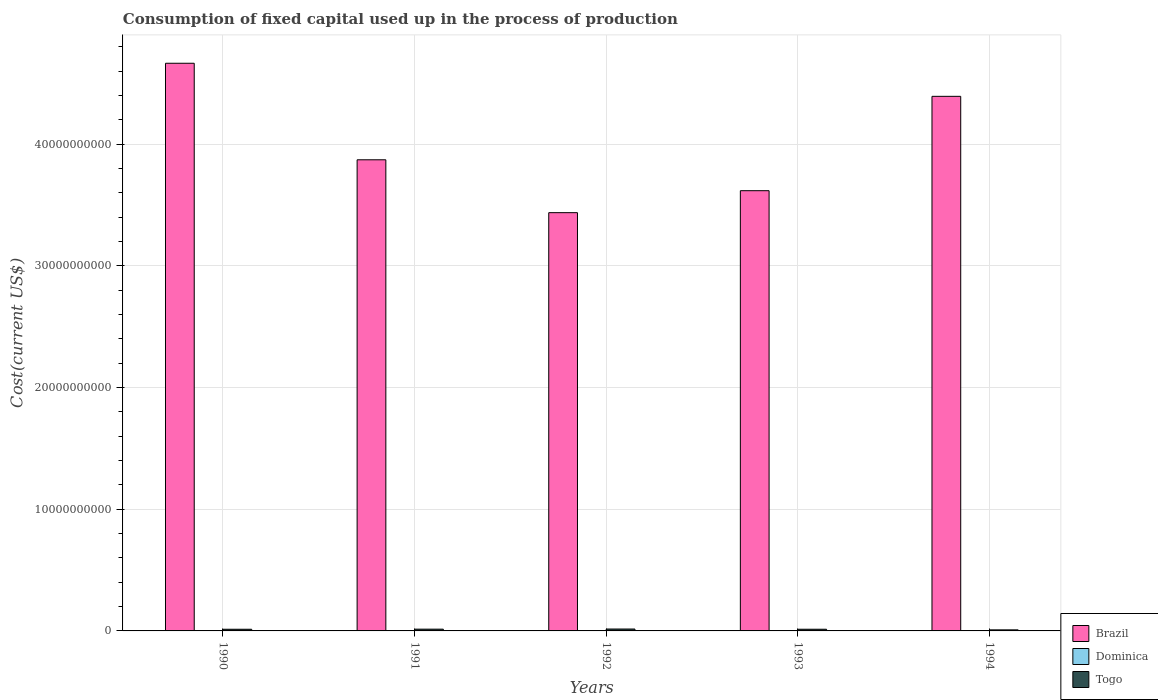How many groups of bars are there?
Provide a short and direct response. 5. Are the number of bars per tick equal to the number of legend labels?
Your answer should be very brief. Yes. Are the number of bars on each tick of the X-axis equal?
Keep it short and to the point. Yes. How many bars are there on the 4th tick from the left?
Provide a short and direct response. 3. In how many cases, is the number of bars for a given year not equal to the number of legend labels?
Keep it short and to the point. 0. What is the amount consumed in the process of production in Brazil in 1994?
Your response must be concise. 4.39e+1. Across all years, what is the maximum amount consumed in the process of production in Togo?
Offer a terse response. 1.56e+08. Across all years, what is the minimum amount consumed in the process of production in Brazil?
Your answer should be very brief. 3.44e+1. In which year was the amount consumed in the process of production in Dominica minimum?
Keep it short and to the point. 1990. What is the total amount consumed in the process of production in Dominica in the graph?
Your answer should be very brief. 4.10e+07. What is the difference between the amount consumed in the process of production in Dominica in 1992 and that in 1993?
Provide a short and direct response. -5.16e+05. What is the difference between the amount consumed in the process of production in Dominica in 1992 and the amount consumed in the process of production in Brazil in 1990?
Make the answer very short. -4.66e+1. What is the average amount consumed in the process of production in Brazil per year?
Your response must be concise. 4.00e+1. In the year 1994, what is the difference between the amount consumed in the process of production in Brazil and amount consumed in the process of production in Dominica?
Provide a short and direct response. 4.39e+1. In how many years, is the amount consumed in the process of production in Dominica greater than 36000000000 US$?
Your answer should be compact. 0. What is the ratio of the amount consumed in the process of production in Brazil in 1990 to that in 1991?
Provide a succinct answer. 1.2. What is the difference between the highest and the second highest amount consumed in the process of production in Brazil?
Keep it short and to the point. 2.72e+09. What is the difference between the highest and the lowest amount consumed in the process of production in Togo?
Ensure brevity in your answer.  6.89e+07. In how many years, is the amount consumed in the process of production in Togo greater than the average amount consumed in the process of production in Togo taken over all years?
Make the answer very short. 4. Is it the case that in every year, the sum of the amount consumed in the process of production in Brazil and amount consumed in the process of production in Dominica is greater than the amount consumed in the process of production in Togo?
Ensure brevity in your answer.  Yes. Are all the bars in the graph horizontal?
Give a very brief answer. No. How many years are there in the graph?
Your answer should be compact. 5. Are the values on the major ticks of Y-axis written in scientific E-notation?
Offer a terse response. No. Does the graph contain any zero values?
Your response must be concise. No. Does the graph contain grids?
Provide a succinct answer. Yes. What is the title of the graph?
Provide a short and direct response. Consumption of fixed capital used up in the process of production. What is the label or title of the X-axis?
Ensure brevity in your answer.  Years. What is the label or title of the Y-axis?
Make the answer very short. Cost(current US$). What is the Cost(current US$) in Brazil in 1990?
Make the answer very short. 4.66e+1. What is the Cost(current US$) in Dominica in 1990?
Provide a short and direct response. 6.67e+06. What is the Cost(current US$) in Togo in 1990?
Ensure brevity in your answer.  1.37e+08. What is the Cost(current US$) of Brazil in 1991?
Your answer should be compact. 3.87e+1. What is the Cost(current US$) in Dominica in 1991?
Keep it short and to the point. 7.73e+06. What is the Cost(current US$) in Togo in 1991?
Offer a terse response. 1.44e+08. What is the Cost(current US$) of Brazil in 1992?
Give a very brief answer. 3.44e+1. What is the Cost(current US$) in Dominica in 1992?
Give a very brief answer. 8.29e+06. What is the Cost(current US$) of Togo in 1992?
Your answer should be very brief. 1.56e+08. What is the Cost(current US$) in Brazil in 1993?
Your answer should be very brief. 3.62e+1. What is the Cost(current US$) of Dominica in 1993?
Give a very brief answer. 8.80e+06. What is the Cost(current US$) in Togo in 1993?
Offer a terse response. 1.38e+08. What is the Cost(current US$) in Brazil in 1994?
Make the answer very short. 4.39e+1. What is the Cost(current US$) of Dominica in 1994?
Your response must be concise. 9.56e+06. What is the Cost(current US$) in Togo in 1994?
Ensure brevity in your answer.  8.72e+07. Across all years, what is the maximum Cost(current US$) in Brazil?
Ensure brevity in your answer.  4.66e+1. Across all years, what is the maximum Cost(current US$) in Dominica?
Provide a short and direct response. 9.56e+06. Across all years, what is the maximum Cost(current US$) in Togo?
Your answer should be very brief. 1.56e+08. Across all years, what is the minimum Cost(current US$) of Brazil?
Give a very brief answer. 3.44e+1. Across all years, what is the minimum Cost(current US$) in Dominica?
Your answer should be very brief. 6.67e+06. Across all years, what is the minimum Cost(current US$) of Togo?
Provide a short and direct response. 8.72e+07. What is the total Cost(current US$) of Brazil in the graph?
Your answer should be very brief. 2.00e+11. What is the total Cost(current US$) in Dominica in the graph?
Offer a terse response. 4.10e+07. What is the total Cost(current US$) in Togo in the graph?
Your answer should be very brief. 6.63e+08. What is the difference between the Cost(current US$) in Brazil in 1990 and that in 1991?
Offer a very short reply. 7.93e+09. What is the difference between the Cost(current US$) in Dominica in 1990 and that in 1991?
Provide a succinct answer. -1.06e+06. What is the difference between the Cost(current US$) of Togo in 1990 and that in 1991?
Provide a succinct answer. -6.68e+06. What is the difference between the Cost(current US$) in Brazil in 1990 and that in 1992?
Provide a short and direct response. 1.23e+1. What is the difference between the Cost(current US$) in Dominica in 1990 and that in 1992?
Your answer should be compact. -1.62e+06. What is the difference between the Cost(current US$) in Togo in 1990 and that in 1992?
Make the answer very short. -1.88e+07. What is the difference between the Cost(current US$) of Brazil in 1990 and that in 1993?
Your answer should be very brief. 1.05e+1. What is the difference between the Cost(current US$) of Dominica in 1990 and that in 1993?
Keep it short and to the point. -2.13e+06. What is the difference between the Cost(current US$) in Togo in 1990 and that in 1993?
Provide a short and direct response. -6.47e+05. What is the difference between the Cost(current US$) of Brazil in 1990 and that in 1994?
Offer a terse response. 2.72e+09. What is the difference between the Cost(current US$) in Dominica in 1990 and that in 1994?
Your answer should be very brief. -2.90e+06. What is the difference between the Cost(current US$) in Togo in 1990 and that in 1994?
Make the answer very short. 5.01e+07. What is the difference between the Cost(current US$) of Brazil in 1991 and that in 1992?
Your answer should be compact. 4.34e+09. What is the difference between the Cost(current US$) in Dominica in 1991 and that in 1992?
Keep it short and to the point. -5.60e+05. What is the difference between the Cost(current US$) in Togo in 1991 and that in 1992?
Your answer should be compact. -1.21e+07. What is the difference between the Cost(current US$) of Brazil in 1991 and that in 1993?
Keep it short and to the point. 2.54e+09. What is the difference between the Cost(current US$) in Dominica in 1991 and that in 1993?
Give a very brief answer. -1.08e+06. What is the difference between the Cost(current US$) in Togo in 1991 and that in 1993?
Keep it short and to the point. 6.03e+06. What is the difference between the Cost(current US$) of Brazil in 1991 and that in 1994?
Your response must be concise. -5.22e+09. What is the difference between the Cost(current US$) of Dominica in 1991 and that in 1994?
Ensure brevity in your answer.  -1.84e+06. What is the difference between the Cost(current US$) of Togo in 1991 and that in 1994?
Give a very brief answer. 5.68e+07. What is the difference between the Cost(current US$) of Brazil in 1992 and that in 1993?
Keep it short and to the point. -1.81e+09. What is the difference between the Cost(current US$) in Dominica in 1992 and that in 1993?
Provide a short and direct response. -5.16e+05. What is the difference between the Cost(current US$) in Togo in 1992 and that in 1993?
Offer a terse response. 1.81e+07. What is the difference between the Cost(current US$) in Brazil in 1992 and that in 1994?
Your answer should be very brief. -9.56e+09. What is the difference between the Cost(current US$) in Dominica in 1992 and that in 1994?
Provide a short and direct response. -1.28e+06. What is the difference between the Cost(current US$) in Togo in 1992 and that in 1994?
Your answer should be very brief. 6.89e+07. What is the difference between the Cost(current US$) in Brazil in 1993 and that in 1994?
Ensure brevity in your answer.  -7.75e+09. What is the difference between the Cost(current US$) of Dominica in 1993 and that in 1994?
Your answer should be compact. -7.61e+05. What is the difference between the Cost(current US$) in Togo in 1993 and that in 1994?
Offer a terse response. 5.07e+07. What is the difference between the Cost(current US$) in Brazil in 1990 and the Cost(current US$) in Dominica in 1991?
Keep it short and to the point. 4.66e+1. What is the difference between the Cost(current US$) in Brazil in 1990 and the Cost(current US$) in Togo in 1991?
Provide a succinct answer. 4.65e+1. What is the difference between the Cost(current US$) in Dominica in 1990 and the Cost(current US$) in Togo in 1991?
Give a very brief answer. -1.37e+08. What is the difference between the Cost(current US$) in Brazil in 1990 and the Cost(current US$) in Dominica in 1992?
Offer a very short reply. 4.66e+1. What is the difference between the Cost(current US$) of Brazil in 1990 and the Cost(current US$) of Togo in 1992?
Offer a very short reply. 4.65e+1. What is the difference between the Cost(current US$) of Dominica in 1990 and the Cost(current US$) of Togo in 1992?
Offer a very short reply. -1.49e+08. What is the difference between the Cost(current US$) of Brazil in 1990 and the Cost(current US$) of Dominica in 1993?
Provide a succinct answer. 4.66e+1. What is the difference between the Cost(current US$) in Brazil in 1990 and the Cost(current US$) in Togo in 1993?
Give a very brief answer. 4.65e+1. What is the difference between the Cost(current US$) in Dominica in 1990 and the Cost(current US$) in Togo in 1993?
Offer a terse response. -1.31e+08. What is the difference between the Cost(current US$) of Brazil in 1990 and the Cost(current US$) of Dominica in 1994?
Offer a terse response. 4.66e+1. What is the difference between the Cost(current US$) in Brazil in 1990 and the Cost(current US$) in Togo in 1994?
Offer a terse response. 4.66e+1. What is the difference between the Cost(current US$) in Dominica in 1990 and the Cost(current US$) in Togo in 1994?
Ensure brevity in your answer.  -8.05e+07. What is the difference between the Cost(current US$) of Brazil in 1991 and the Cost(current US$) of Dominica in 1992?
Offer a very short reply. 3.87e+1. What is the difference between the Cost(current US$) of Brazil in 1991 and the Cost(current US$) of Togo in 1992?
Offer a very short reply. 3.86e+1. What is the difference between the Cost(current US$) of Dominica in 1991 and the Cost(current US$) of Togo in 1992?
Ensure brevity in your answer.  -1.48e+08. What is the difference between the Cost(current US$) in Brazil in 1991 and the Cost(current US$) in Dominica in 1993?
Keep it short and to the point. 3.87e+1. What is the difference between the Cost(current US$) in Brazil in 1991 and the Cost(current US$) in Togo in 1993?
Ensure brevity in your answer.  3.86e+1. What is the difference between the Cost(current US$) of Dominica in 1991 and the Cost(current US$) of Togo in 1993?
Offer a very short reply. -1.30e+08. What is the difference between the Cost(current US$) of Brazil in 1991 and the Cost(current US$) of Dominica in 1994?
Keep it short and to the point. 3.87e+1. What is the difference between the Cost(current US$) in Brazil in 1991 and the Cost(current US$) in Togo in 1994?
Your response must be concise. 3.86e+1. What is the difference between the Cost(current US$) in Dominica in 1991 and the Cost(current US$) in Togo in 1994?
Offer a very short reply. -7.95e+07. What is the difference between the Cost(current US$) of Brazil in 1992 and the Cost(current US$) of Dominica in 1993?
Provide a succinct answer. 3.44e+1. What is the difference between the Cost(current US$) in Brazil in 1992 and the Cost(current US$) in Togo in 1993?
Your answer should be very brief. 3.42e+1. What is the difference between the Cost(current US$) of Dominica in 1992 and the Cost(current US$) of Togo in 1993?
Your answer should be compact. -1.30e+08. What is the difference between the Cost(current US$) in Brazil in 1992 and the Cost(current US$) in Dominica in 1994?
Provide a succinct answer. 3.44e+1. What is the difference between the Cost(current US$) of Brazil in 1992 and the Cost(current US$) of Togo in 1994?
Keep it short and to the point. 3.43e+1. What is the difference between the Cost(current US$) of Dominica in 1992 and the Cost(current US$) of Togo in 1994?
Ensure brevity in your answer.  -7.89e+07. What is the difference between the Cost(current US$) in Brazil in 1993 and the Cost(current US$) in Dominica in 1994?
Offer a terse response. 3.62e+1. What is the difference between the Cost(current US$) in Brazil in 1993 and the Cost(current US$) in Togo in 1994?
Ensure brevity in your answer.  3.61e+1. What is the difference between the Cost(current US$) of Dominica in 1993 and the Cost(current US$) of Togo in 1994?
Your response must be concise. -7.84e+07. What is the average Cost(current US$) of Brazil per year?
Ensure brevity in your answer.  4.00e+1. What is the average Cost(current US$) in Dominica per year?
Your response must be concise. 8.21e+06. What is the average Cost(current US$) in Togo per year?
Provide a short and direct response. 1.33e+08. In the year 1990, what is the difference between the Cost(current US$) in Brazil and Cost(current US$) in Dominica?
Make the answer very short. 4.66e+1. In the year 1990, what is the difference between the Cost(current US$) of Brazil and Cost(current US$) of Togo?
Your response must be concise. 4.65e+1. In the year 1990, what is the difference between the Cost(current US$) of Dominica and Cost(current US$) of Togo?
Provide a short and direct response. -1.31e+08. In the year 1991, what is the difference between the Cost(current US$) in Brazil and Cost(current US$) in Dominica?
Your answer should be very brief. 3.87e+1. In the year 1991, what is the difference between the Cost(current US$) in Brazil and Cost(current US$) in Togo?
Make the answer very short. 3.86e+1. In the year 1991, what is the difference between the Cost(current US$) of Dominica and Cost(current US$) of Togo?
Your response must be concise. -1.36e+08. In the year 1992, what is the difference between the Cost(current US$) in Brazil and Cost(current US$) in Dominica?
Offer a terse response. 3.44e+1. In the year 1992, what is the difference between the Cost(current US$) in Brazil and Cost(current US$) in Togo?
Your answer should be very brief. 3.42e+1. In the year 1992, what is the difference between the Cost(current US$) in Dominica and Cost(current US$) in Togo?
Your answer should be compact. -1.48e+08. In the year 1993, what is the difference between the Cost(current US$) in Brazil and Cost(current US$) in Dominica?
Offer a very short reply. 3.62e+1. In the year 1993, what is the difference between the Cost(current US$) in Brazil and Cost(current US$) in Togo?
Provide a short and direct response. 3.60e+1. In the year 1993, what is the difference between the Cost(current US$) in Dominica and Cost(current US$) in Togo?
Make the answer very short. -1.29e+08. In the year 1994, what is the difference between the Cost(current US$) in Brazil and Cost(current US$) in Dominica?
Give a very brief answer. 4.39e+1. In the year 1994, what is the difference between the Cost(current US$) of Brazil and Cost(current US$) of Togo?
Provide a short and direct response. 4.38e+1. In the year 1994, what is the difference between the Cost(current US$) in Dominica and Cost(current US$) in Togo?
Your answer should be compact. -7.76e+07. What is the ratio of the Cost(current US$) in Brazil in 1990 to that in 1991?
Make the answer very short. 1.2. What is the ratio of the Cost(current US$) in Dominica in 1990 to that in 1991?
Your answer should be very brief. 0.86. What is the ratio of the Cost(current US$) of Togo in 1990 to that in 1991?
Keep it short and to the point. 0.95. What is the ratio of the Cost(current US$) in Brazil in 1990 to that in 1992?
Provide a short and direct response. 1.36. What is the ratio of the Cost(current US$) in Dominica in 1990 to that in 1992?
Give a very brief answer. 0.8. What is the ratio of the Cost(current US$) of Togo in 1990 to that in 1992?
Provide a short and direct response. 0.88. What is the ratio of the Cost(current US$) in Brazil in 1990 to that in 1993?
Give a very brief answer. 1.29. What is the ratio of the Cost(current US$) of Dominica in 1990 to that in 1993?
Your answer should be compact. 0.76. What is the ratio of the Cost(current US$) of Brazil in 1990 to that in 1994?
Offer a terse response. 1.06. What is the ratio of the Cost(current US$) in Dominica in 1990 to that in 1994?
Offer a terse response. 0.7. What is the ratio of the Cost(current US$) in Togo in 1990 to that in 1994?
Give a very brief answer. 1.57. What is the ratio of the Cost(current US$) of Brazil in 1991 to that in 1992?
Offer a terse response. 1.13. What is the ratio of the Cost(current US$) in Dominica in 1991 to that in 1992?
Provide a succinct answer. 0.93. What is the ratio of the Cost(current US$) in Togo in 1991 to that in 1992?
Keep it short and to the point. 0.92. What is the ratio of the Cost(current US$) of Brazil in 1991 to that in 1993?
Offer a very short reply. 1.07. What is the ratio of the Cost(current US$) of Dominica in 1991 to that in 1993?
Give a very brief answer. 0.88. What is the ratio of the Cost(current US$) of Togo in 1991 to that in 1993?
Make the answer very short. 1.04. What is the ratio of the Cost(current US$) of Brazil in 1991 to that in 1994?
Keep it short and to the point. 0.88. What is the ratio of the Cost(current US$) of Dominica in 1991 to that in 1994?
Make the answer very short. 0.81. What is the ratio of the Cost(current US$) of Togo in 1991 to that in 1994?
Provide a short and direct response. 1.65. What is the ratio of the Cost(current US$) in Brazil in 1992 to that in 1993?
Your answer should be very brief. 0.95. What is the ratio of the Cost(current US$) in Dominica in 1992 to that in 1993?
Your answer should be very brief. 0.94. What is the ratio of the Cost(current US$) in Togo in 1992 to that in 1993?
Provide a succinct answer. 1.13. What is the ratio of the Cost(current US$) of Brazil in 1992 to that in 1994?
Your response must be concise. 0.78. What is the ratio of the Cost(current US$) of Dominica in 1992 to that in 1994?
Your response must be concise. 0.87. What is the ratio of the Cost(current US$) of Togo in 1992 to that in 1994?
Your answer should be very brief. 1.79. What is the ratio of the Cost(current US$) in Brazil in 1993 to that in 1994?
Give a very brief answer. 0.82. What is the ratio of the Cost(current US$) of Dominica in 1993 to that in 1994?
Keep it short and to the point. 0.92. What is the ratio of the Cost(current US$) in Togo in 1993 to that in 1994?
Offer a terse response. 1.58. What is the difference between the highest and the second highest Cost(current US$) of Brazil?
Keep it short and to the point. 2.72e+09. What is the difference between the highest and the second highest Cost(current US$) in Dominica?
Your answer should be compact. 7.61e+05. What is the difference between the highest and the second highest Cost(current US$) of Togo?
Offer a terse response. 1.21e+07. What is the difference between the highest and the lowest Cost(current US$) in Brazil?
Offer a terse response. 1.23e+1. What is the difference between the highest and the lowest Cost(current US$) in Dominica?
Offer a very short reply. 2.90e+06. What is the difference between the highest and the lowest Cost(current US$) of Togo?
Keep it short and to the point. 6.89e+07. 